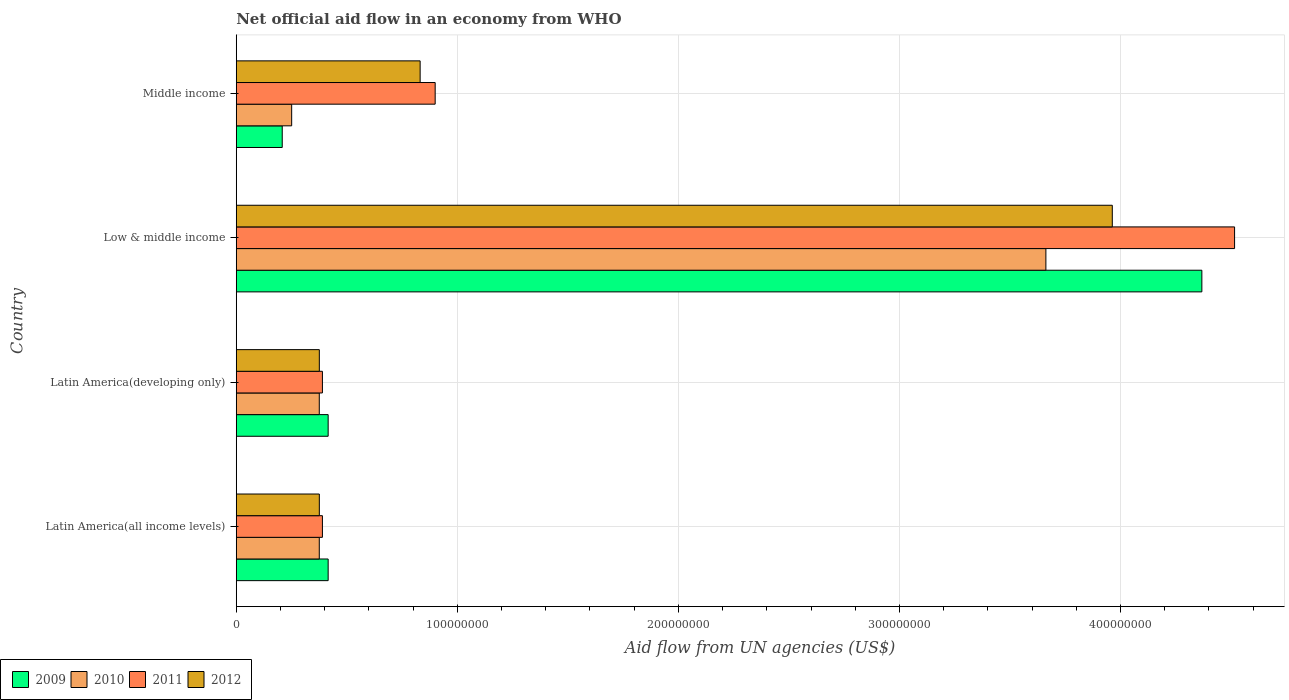Are the number of bars per tick equal to the number of legend labels?
Give a very brief answer. Yes. How many bars are there on the 2nd tick from the bottom?
Give a very brief answer. 4. In how many cases, is the number of bars for a given country not equal to the number of legend labels?
Keep it short and to the point. 0. What is the net official aid flow in 2011 in Low & middle income?
Provide a short and direct response. 4.52e+08. Across all countries, what is the maximum net official aid flow in 2009?
Your answer should be very brief. 4.37e+08. Across all countries, what is the minimum net official aid flow in 2010?
Keep it short and to the point. 2.51e+07. In which country was the net official aid flow in 2009 maximum?
Provide a short and direct response. Low & middle income. What is the total net official aid flow in 2010 in the graph?
Keep it short and to the point. 4.66e+08. What is the difference between the net official aid flow in 2012 in Latin America(developing only) and that in Low & middle income?
Ensure brevity in your answer.  -3.59e+08. What is the difference between the net official aid flow in 2011 in Latin America(all income levels) and the net official aid flow in 2010 in Middle income?
Make the answer very short. 1.39e+07. What is the average net official aid flow in 2009 per country?
Offer a very short reply. 1.35e+08. What is the difference between the net official aid flow in 2012 and net official aid flow in 2011 in Latin America(developing only)?
Ensure brevity in your answer.  -1.40e+06. What is the ratio of the net official aid flow in 2010 in Latin America(all income levels) to that in Low & middle income?
Your response must be concise. 0.1. Is the net official aid flow in 2009 in Low & middle income less than that in Middle income?
Give a very brief answer. No. Is the difference between the net official aid flow in 2012 in Latin America(all income levels) and Low & middle income greater than the difference between the net official aid flow in 2011 in Latin America(all income levels) and Low & middle income?
Ensure brevity in your answer.  Yes. What is the difference between the highest and the second highest net official aid flow in 2009?
Ensure brevity in your answer.  3.95e+08. What is the difference between the highest and the lowest net official aid flow in 2009?
Keep it short and to the point. 4.16e+08. In how many countries, is the net official aid flow in 2010 greater than the average net official aid flow in 2010 taken over all countries?
Provide a short and direct response. 1. Is it the case that in every country, the sum of the net official aid flow in 2009 and net official aid flow in 2011 is greater than the sum of net official aid flow in 2010 and net official aid flow in 2012?
Your answer should be compact. No. What does the 2nd bar from the top in Latin America(all income levels) represents?
Ensure brevity in your answer.  2011. Is it the case that in every country, the sum of the net official aid flow in 2009 and net official aid flow in 2010 is greater than the net official aid flow in 2012?
Offer a very short reply. No. How many bars are there?
Your answer should be compact. 16. How many countries are there in the graph?
Make the answer very short. 4. Are the values on the major ticks of X-axis written in scientific E-notation?
Offer a very short reply. No. Does the graph contain any zero values?
Your answer should be very brief. No. Does the graph contain grids?
Your answer should be very brief. Yes. Where does the legend appear in the graph?
Your answer should be very brief. Bottom left. What is the title of the graph?
Keep it short and to the point. Net official aid flow in an economy from WHO. Does "1975" appear as one of the legend labels in the graph?
Provide a short and direct response. No. What is the label or title of the X-axis?
Give a very brief answer. Aid flow from UN agencies (US$). What is the Aid flow from UN agencies (US$) of 2009 in Latin America(all income levels)?
Keep it short and to the point. 4.16e+07. What is the Aid flow from UN agencies (US$) in 2010 in Latin America(all income levels)?
Your response must be concise. 3.76e+07. What is the Aid flow from UN agencies (US$) of 2011 in Latin America(all income levels)?
Offer a terse response. 3.90e+07. What is the Aid flow from UN agencies (US$) in 2012 in Latin America(all income levels)?
Provide a succinct answer. 3.76e+07. What is the Aid flow from UN agencies (US$) in 2009 in Latin America(developing only)?
Ensure brevity in your answer.  4.16e+07. What is the Aid flow from UN agencies (US$) in 2010 in Latin America(developing only)?
Provide a short and direct response. 3.76e+07. What is the Aid flow from UN agencies (US$) of 2011 in Latin America(developing only)?
Your answer should be very brief. 3.90e+07. What is the Aid flow from UN agencies (US$) of 2012 in Latin America(developing only)?
Offer a terse response. 3.76e+07. What is the Aid flow from UN agencies (US$) in 2009 in Low & middle income?
Make the answer very short. 4.37e+08. What is the Aid flow from UN agencies (US$) of 2010 in Low & middle income?
Keep it short and to the point. 3.66e+08. What is the Aid flow from UN agencies (US$) in 2011 in Low & middle income?
Provide a short and direct response. 4.52e+08. What is the Aid flow from UN agencies (US$) in 2012 in Low & middle income?
Keep it short and to the point. 3.96e+08. What is the Aid flow from UN agencies (US$) in 2009 in Middle income?
Your answer should be compact. 2.08e+07. What is the Aid flow from UN agencies (US$) of 2010 in Middle income?
Keep it short and to the point. 2.51e+07. What is the Aid flow from UN agencies (US$) of 2011 in Middle income?
Make the answer very short. 9.00e+07. What is the Aid flow from UN agencies (US$) in 2012 in Middle income?
Offer a very short reply. 8.32e+07. Across all countries, what is the maximum Aid flow from UN agencies (US$) in 2009?
Give a very brief answer. 4.37e+08. Across all countries, what is the maximum Aid flow from UN agencies (US$) in 2010?
Offer a very short reply. 3.66e+08. Across all countries, what is the maximum Aid flow from UN agencies (US$) in 2011?
Keep it short and to the point. 4.52e+08. Across all countries, what is the maximum Aid flow from UN agencies (US$) of 2012?
Your answer should be compact. 3.96e+08. Across all countries, what is the minimum Aid flow from UN agencies (US$) in 2009?
Offer a very short reply. 2.08e+07. Across all countries, what is the minimum Aid flow from UN agencies (US$) in 2010?
Make the answer very short. 2.51e+07. Across all countries, what is the minimum Aid flow from UN agencies (US$) of 2011?
Give a very brief answer. 3.90e+07. Across all countries, what is the minimum Aid flow from UN agencies (US$) in 2012?
Your answer should be very brief. 3.76e+07. What is the total Aid flow from UN agencies (US$) in 2009 in the graph?
Keep it short and to the point. 5.41e+08. What is the total Aid flow from UN agencies (US$) of 2010 in the graph?
Your answer should be very brief. 4.66e+08. What is the total Aid flow from UN agencies (US$) in 2011 in the graph?
Your response must be concise. 6.20e+08. What is the total Aid flow from UN agencies (US$) in 2012 in the graph?
Provide a succinct answer. 5.55e+08. What is the difference between the Aid flow from UN agencies (US$) of 2010 in Latin America(all income levels) and that in Latin America(developing only)?
Provide a short and direct response. 0. What is the difference between the Aid flow from UN agencies (US$) in 2009 in Latin America(all income levels) and that in Low & middle income?
Keep it short and to the point. -3.95e+08. What is the difference between the Aid flow from UN agencies (US$) of 2010 in Latin America(all income levels) and that in Low & middle income?
Provide a short and direct response. -3.29e+08. What is the difference between the Aid flow from UN agencies (US$) of 2011 in Latin America(all income levels) and that in Low & middle income?
Your answer should be very brief. -4.13e+08. What is the difference between the Aid flow from UN agencies (US$) in 2012 in Latin America(all income levels) and that in Low & middle income?
Your response must be concise. -3.59e+08. What is the difference between the Aid flow from UN agencies (US$) in 2009 in Latin America(all income levels) and that in Middle income?
Provide a short and direct response. 2.08e+07. What is the difference between the Aid flow from UN agencies (US$) of 2010 in Latin America(all income levels) and that in Middle income?
Provide a short and direct response. 1.25e+07. What is the difference between the Aid flow from UN agencies (US$) in 2011 in Latin America(all income levels) and that in Middle income?
Your response must be concise. -5.10e+07. What is the difference between the Aid flow from UN agencies (US$) of 2012 in Latin America(all income levels) and that in Middle income?
Your answer should be compact. -4.56e+07. What is the difference between the Aid flow from UN agencies (US$) in 2009 in Latin America(developing only) and that in Low & middle income?
Provide a succinct answer. -3.95e+08. What is the difference between the Aid flow from UN agencies (US$) in 2010 in Latin America(developing only) and that in Low & middle income?
Your response must be concise. -3.29e+08. What is the difference between the Aid flow from UN agencies (US$) of 2011 in Latin America(developing only) and that in Low & middle income?
Your answer should be compact. -4.13e+08. What is the difference between the Aid flow from UN agencies (US$) in 2012 in Latin America(developing only) and that in Low & middle income?
Offer a terse response. -3.59e+08. What is the difference between the Aid flow from UN agencies (US$) in 2009 in Latin America(developing only) and that in Middle income?
Provide a succinct answer. 2.08e+07. What is the difference between the Aid flow from UN agencies (US$) of 2010 in Latin America(developing only) and that in Middle income?
Provide a succinct answer. 1.25e+07. What is the difference between the Aid flow from UN agencies (US$) in 2011 in Latin America(developing only) and that in Middle income?
Your answer should be very brief. -5.10e+07. What is the difference between the Aid flow from UN agencies (US$) of 2012 in Latin America(developing only) and that in Middle income?
Provide a succinct answer. -4.56e+07. What is the difference between the Aid flow from UN agencies (US$) of 2009 in Low & middle income and that in Middle income?
Give a very brief answer. 4.16e+08. What is the difference between the Aid flow from UN agencies (US$) in 2010 in Low & middle income and that in Middle income?
Ensure brevity in your answer.  3.41e+08. What is the difference between the Aid flow from UN agencies (US$) in 2011 in Low & middle income and that in Middle income?
Ensure brevity in your answer.  3.62e+08. What is the difference between the Aid flow from UN agencies (US$) in 2012 in Low & middle income and that in Middle income?
Your answer should be compact. 3.13e+08. What is the difference between the Aid flow from UN agencies (US$) of 2009 in Latin America(all income levels) and the Aid flow from UN agencies (US$) of 2010 in Latin America(developing only)?
Offer a terse response. 4.01e+06. What is the difference between the Aid flow from UN agencies (US$) in 2009 in Latin America(all income levels) and the Aid flow from UN agencies (US$) in 2011 in Latin America(developing only)?
Make the answer very short. 2.59e+06. What is the difference between the Aid flow from UN agencies (US$) in 2009 in Latin America(all income levels) and the Aid flow from UN agencies (US$) in 2012 in Latin America(developing only)?
Make the answer very short. 3.99e+06. What is the difference between the Aid flow from UN agencies (US$) of 2010 in Latin America(all income levels) and the Aid flow from UN agencies (US$) of 2011 in Latin America(developing only)?
Provide a short and direct response. -1.42e+06. What is the difference between the Aid flow from UN agencies (US$) of 2011 in Latin America(all income levels) and the Aid flow from UN agencies (US$) of 2012 in Latin America(developing only)?
Ensure brevity in your answer.  1.40e+06. What is the difference between the Aid flow from UN agencies (US$) in 2009 in Latin America(all income levels) and the Aid flow from UN agencies (US$) in 2010 in Low & middle income?
Keep it short and to the point. -3.25e+08. What is the difference between the Aid flow from UN agencies (US$) in 2009 in Latin America(all income levels) and the Aid flow from UN agencies (US$) in 2011 in Low & middle income?
Make the answer very short. -4.10e+08. What is the difference between the Aid flow from UN agencies (US$) in 2009 in Latin America(all income levels) and the Aid flow from UN agencies (US$) in 2012 in Low & middle income?
Your response must be concise. -3.55e+08. What is the difference between the Aid flow from UN agencies (US$) of 2010 in Latin America(all income levels) and the Aid flow from UN agencies (US$) of 2011 in Low & middle income?
Your answer should be very brief. -4.14e+08. What is the difference between the Aid flow from UN agencies (US$) in 2010 in Latin America(all income levels) and the Aid flow from UN agencies (US$) in 2012 in Low & middle income?
Your answer should be compact. -3.59e+08. What is the difference between the Aid flow from UN agencies (US$) in 2011 in Latin America(all income levels) and the Aid flow from UN agencies (US$) in 2012 in Low & middle income?
Keep it short and to the point. -3.57e+08. What is the difference between the Aid flow from UN agencies (US$) in 2009 in Latin America(all income levels) and the Aid flow from UN agencies (US$) in 2010 in Middle income?
Your response must be concise. 1.65e+07. What is the difference between the Aid flow from UN agencies (US$) of 2009 in Latin America(all income levels) and the Aid flow from UN agencies (US$) of 2011 in Middle income?
Provide a short and direct response. -4.84e+07. What is the difference between the Aid flow from UN agencies (US$) in 2009 in Latin America(all income levels) and the Aid flow from UN agencies (US$) in 2012 in Middle income?
Your answer should be compact. -4.16e+07. What is the difference between the Aid flow from UN agencies (US$) in 2010 in Latin America(all income levels) and the Aid flow from UN agencies (US$) in 2011 in Middle income?
Provide a short and direct response. -5.24e+07. What is the difference between the Aid flow from UN agencies (US$) in 2010 in Latin America(all income levels) and the Aid flow from UN agencies (US$) in 2012 in Middle income?
Your answer should be very brief. -4.56e+07. What is the difference between the Aid flow from UN agencies (US$) of 2011 in Latin America(all income levels) and the Aid flow from UN agencies (US$) of 2012 in Middle income?
Your answer should be very brief. -4.42e+07. What is the difference between the Aid flow from UN agencies (US$) in 2009 in Latin America(developing only) and the Aid flow from UN agencies (US$) in 2010 in Low & middle income?
Offer a terse response. -3.25e+08. What is the difference between the Aid flow from UN agencies (US$) of 2009 in Latin America(developing only) and the Aid flow from UN agencies (US$) of 2011 in Low & middle income?
Your response must be concise. -4.10e+08. What is the difference between the Aid flow from UN agencies (US$) in 2009 in Latin America(developing only) and the Aid flow from UN agencies (US$) in 2012 in Low & middle income?
Provide a succinct answer. -3.55e+08. What is the difference between the Aid flow from UN agencies (US$) in 2010 in Latin America(developing only) and the Aid flow from UN agencies (US$) in 2011 in Low & middle income?
Offer a very short reply. -4.14e+08. What is the difference between the Aid flow from UN agencies (US$) of 2010 in Latin America(developing only) and the Aid flow from UN agencies (US$) of 2012 in Low & middle income?
Your answer should be very brief. -3.59e+08. What is the difference between the Aid flow from UN agencies (US$) in 2011 in Latin America(developing only) and the Aid flow from UN agencies (US$) in 2012 in Low & middle income?
Provide a short and direct response. -3.57e+08. What is the difference between the Aid flow from UN agencies (US$) in 2009 in Latin America(developing only) and the Aid flow from UN agencies (US$) in 2010 in Middle income?
Keep it short and to the point. 1.65e+07. What is the difference between the Aid flow from UN agencies (US$) of 2009 in Latin America(developing only) and the Aid flow from UN agencies (US$) of 2011 in Middle income?
Ensure brevity in your answer.  -4.84e+07. What is the difference between the Aid flow from UN agencies (US$) in 2009 in Latin America(developing only) and the Aid flow from UN agencies (US$) in 2012 in Middle income?
Your response must be concise. -4.16e+07. What is the difference between the Aid flow from UN agencies (US$) of 2010 in Latin America(developing only) and the Aid flow from UN agencies (US$) of 2011 in Middle income?
Your response must be concise. -5.24e+07. What is the difference between the Aid flow from UN agencies (US$) of 2010 in Latin America(developing only) and the Aid flow from UN agencies (US$) of 2012 in Middle income?
Provide a short and direct response. -4.56e+07. What is the difference between the Aid flow from UN agencies (US$) in 2011 in Latin America(developing only) and the Aid flow from UN agencies (US$) in 2012 in Middle income?
Provide a short and direct response. -4.42e+07. What is the difference between the Aid flow from UN agencies (US$) in 2009 in Low & middle income and the Aid flow from UN agencies (US$) in 2010 in Middle income?
Keep it short and to the point. 4.12e+08. What is the difference between the Aid flow from UN agencies (US$) of 2009 in Low & middle income and the Aid flow from UN agencies (US$) of 2011 in Middle income?
Ensure brevity in your answer.  3.47e+08. What is the difference between the Aid flow from UN agencies (US$) in 2009 in Low & middle income and the Aid flow from UN agencies (US$) in 2012 in Middle income?
Give a very brief answer. 3.54e+08. What is the difference between the Aid flow from UN agencies (US$) of 2010 in Low & middle income and the Aid flow from UN agencies (US$) of 2011 in Middle income?
Keep it short and to the point. 2.76e+08. What is the difference between the Aid flow from UN agencies (US$) in 2010 in Low & middle income and the Aid flow from UN agencies (US$) in 2012 in Middle income?
Give a very brief answer. 2.83e+08. What is the difference between the Aid flow from UN agencies (US$) of 2011 in Low & middle income and the Aid flow from UN agencies (US$) of 2012 in Middle income?
Your answer should be very brief. 3.68e+08. What is the average Aid flow from UN agencies (US$) in 2009 per country?
Your answer should be compact. 1.35e+08. What is the average Aid flow from UN agencies (US$) in 2010 per country?
Offer a very short reply. 1.17e+08. What is the average Aid flow from UN agencies (US$) of 2011 per country?
Make the answer very short. 1.55e+08. What is the average Aid flow from UN agencies (US$) in 2012 per country?
Keep it short and to the point. 1.39e+08. What is the difference between the Aid flow from UN agencies (US$) in 2009 and Aid flow from UN agencies (US$) in 2010 in Latin America(all income levels)?
Your response must be concise. 4.01e+06. What is the difference between the Aid flow from UN agencies (US$) in 2009 and Aid flow from UN agencies (US$) in 2011 in Latin America(all income levels)?
Ensure brevity in your answer.  2.59e+06. What is the difference between the Aid flow from UN agencies (US$) in 2009 and Aid flow from UN agencies (US$) in 2012 in Latin America(all income levels)?
Your response must be concise. 3.99e+06. What is the difference between the Aid flow from UN agencies (US$) of 2010 and Aid flow from UN agencies (US$) of 2011 in Latin America(all income levels)?
Make the answer very short. -1.42e+06. What is the difference between the Aid flow from UN agencies (US$) of 2011 and Aid flow from UN agencies (US$) of 2012 in Latin America(all income levels)?
Your answer should be very brief. 1.40e+06. What is the difference between the Aid flow from UN agencies (US$) in 2009 and Aid flow from UN agencies (US$) in 2010 in Latin America(developing only)?
Your response must be concise. 4.01e+06. What is the difference between the Aid flow from UN agencies (US$) in 2009 and Aid flow from UN agencies (US$) in 2011 in Latin America(developing only)?
Keep it short and to the point. 2.59e+06. What is the difference between the Aid flow from UN agencies (US$) in 2009 and Aid flow from UN agencies (US$) in 2012 in Latin America(developing only)?
Provide a short and direct response. 3.99e+06. What is the difference between the Aid flow from UN agencies (US$) of 2010 and Aid flow from UN agencies (US$) of 2011 in Latin America(developing only)?
Provide a short and direct response. -1.42e+06. What is the difference between the Aid flow from UN agencies (US$) of 2010 and Aid flow from UN agencies (US$) of 2012 in Latin America(developing only)?
Keep it short and to the point. -2.00e+04. What is the difference between the Aid flow from UN agencies (US$) in 2011 and Aid flow from UN agencies (US$) in 2012 in Latin America(developing only)?
Your answer should be compact. 1.40e+06. What is the difference between the Aid flow from UN agencies (US$) in 2009 and Aid flow from UN agencies (US$) in 2010 in Low & middle income?
Offer a terse response. 7.06e+07. What is the difference between the Aid flow from UN agencies (US$) of 2009 and Aid flow from UN agencies (US$) of 2011 in Low & middle income?
Your answer should be very brief. -1.48e+07. What is the difference between the Aid flow from UN agencies (US$) of 2009 and Aid flow from UN agencies (US$) of 2012 in Low & middle income?
Ensure brevity in your answer.  4.05e+07. What is the difference between the Aid flow from UN agencies (US$) in 2010 and Aid flow from UN agencies (US$) in 2011 in Low & middle income?
Your answer should be compact. -8.54e+07. What is the difference between the Aid flow from UN agencies (US$) of 2010 and Aid flow from UN agencies (US$) of 2012 in Low & middle income?
Give a very brief answer. -3.00e+07. What is the difference between the Aid flow from UN agencies (US$) of 2011 and Aid flow from UN agencies (US$) of 2012 in Low & middle income?
Provide a succinct answer. 5.53e+07. What is the difference between the Aid flow from UN agencies (US$) in 2009 and Aid flow from UN agencies (US$) in 2010 in Middle income?
Make the answer very short. -4.27e+06. What is the difference between the Aid flow from UN agencies (US$) of 2009 and Aid flow from UN agencies (US$) of 2011 in Middle income?
Provide a short and direct response. -6.92e+07. What is the difference between the Aid flow from UN agencies (US$) in 2009 and Aid flow from UN agencies (US$) in 2012 in Middle income?
Give a very brief answer. -6.24e+07. What is the difference between the Aid flow from UN agencies (US$) in 2010 and Aid flow from UN agencies (US$) in 2011 in Middle income?
Your answer should be very brief. -6.49e+07. What is the difference between the Aid flow from UN agencies (US$) of 2010 and Aid flow from UN agencies (US$) of 2012 in Middle income?
Provide a succinct answer. -5.81e+07. What is the difference between the Aid flow from UN agencies (US$) of 2011 and Aid flow from UN agencies (US$) of 2012 in Middle income?
Ensure brevity in your answer.  6.80e+06. What is the ratio of the Aid flow from UN agencies (US$) of 2010 in Latin America(all income levels) to that in Latin America(developing only)?
Offer a very short reply. 1. What is the ratio of the Aid flow from UN agencies (US$) of 2011 in Latin America(all income levels) to that in Latin America(developing only)?
Offer a very short reply. 1. What is the ratio of the Aid flow from UN agencies (US$) of 2009 in Latin America(all income levels) to that in Low & middle income?
Offer a very short reply. 0.1. What is the ratio of the Aid flow from UN agencies (US$) in 2010 in Latin America(all income levels) to that in Low & middle income?
Provide a succinct answer. 0.1. What is the ratio of the Aid flow from UN agencies (US$) in 2011 in Latin America(all income levels) to that in Low & middle income?
Ensure brevity in your answer.  0.09. What is the ratio of the Aid flow from UN agencies (US$) in 2012 in Latin America(all income levels) to that in Low & middle income?
Your answer should be compact. 0.09. What is the ratio of the Aid flow from UN agencies (US$) in 2009 in Latin America(all income levels) to that in Middle income?
Offer a very short reply. 2. What is the ratio of the Aid flow from UN agencies (US$) of 2010 in Latin America(all income levels) to that in Middle income?
Give a very brief answer. 1.5. What is the ratio of the Aid flow from UN agencies (US$) in 2011 in Latin America(all income levels) to that in Middle income?
Your answer should be compact. 0.43. What is the ratio of the Aid flow from UN agencies (US$) of 2012 in Latin America(all income levels) to that in Middle income?
Your response must be concise. 0.45. What is the ratio of the Aid flow from UN agencies (US$) in 2009 in Latin America(developing only) to that in Low & middle income?
Your response must be concise. 0.1. What is the ratio of the Aid flow from UN agencies (US$) in 2010 in Latin America(developing only) to that in Low & middle income?
Give a very brief answer. 0.1. What is the ratio of the Aid flow from UN agencies (US$) in 2011 in Latin America(developing only) to that in Low & middle income?
Give a very brief answer. 0.09. What is the ratio of the Aid flow from UN agencies (US$) in 2012 in Latin America(developing only) to that in Low & middle income?
Make the answer very short. 0.09. What is the ratio of the Aid flow from UN agencies (US$) of 2009 in Latin America(developing only) to that in Middle income?
Your answer should be compact. 2. What is the ratio of the Aid flow from UN agencies (US$) of 2010 in Latin America(developing only) to that in Middle income?
Your response must be concise. 1.5. What is the ratio of the Aid flow from UN agencies (US$) of 2011 in Latin America(developing only) to that in Middle income?
Make the answer very short. 0.43. What is the ratio of the Aid flow from UN agencies (US$) in 2012 in Latin America(developing only) to that in Middle income?
Offer a very short reply. 0.45. What is the ratio of the Aid flow from UN agencies (US$) in 2009 in Low & middle income to that in Middle income?
Provide a succinct answer. 21. What is the ratio of the Aid flow from UN agencies (US$) of 2010 in Low & middle income to that in Middle income?
Your response must be concise. 14.61. What is the ratio of the Aid flow from UN agencies (US$) in 2011 in Low & middle income to that in Middle income?
Your answer should be compact. 5.02. What is the ratio of the Aid flow from UN agencies (US$) of 2012 in Low & middle income to that in Middle income?
Ensure brevity in your answer.  4.76. What is the difference between the highest and the second highest Aid flow from UN agencies (US$) of 2009?
Keep it short and to the point. 3.95e+08. What is the difference between the highest and the second highest Aid flow from UN agencies (US$) of 2010?
Give a very brief answer. 3.29e+08. What is the difference between the highest and the second highest Aid flow from UN agencies (US$) of 2011?
Your answer should be compact. 3.62e+08. What is the difference between the highest and the second highest Aid flow from UN agencies (US$) of 2012?
Make the answer very short. 3.13e+08. What is the difference between the highest and the lowest Aid flow from UN agencies (US$) in 2009?
Your answer should be very brief. 4.16e+08. What is the difference between the highest and the lowest Aid flow from UN agencies (US$) in 2010?
Provide a short and direct response. 3.41e+08. What is the difference between the highest and the lowest Aid flow from UN agencies (US$) in 2011?
Offer a very short reply. 4.13e+08. What is the difference between the highest and the lowest Aid flow from UN agencies (US$) in 2012?
Your answer should be compact. 3.59e+08. 